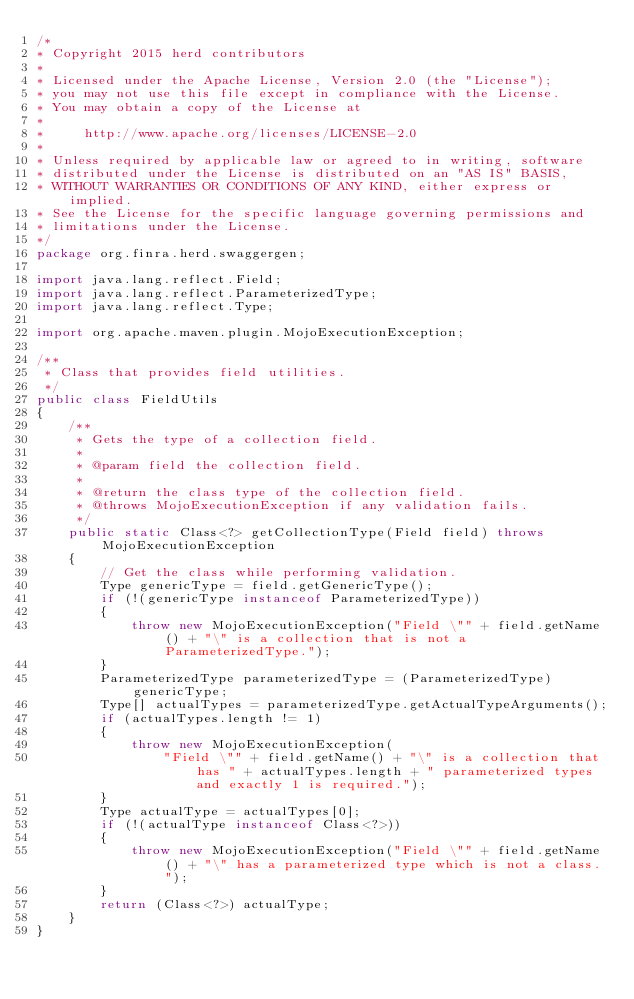Convert code to text. <code><loc_0><loc_0><loc_500><loc_500><_Java_>/*
* Copyright 2015 herd contributors
*
* Licensed under the Apache License, Version 2.0 (the "License");
* you may not use this file except in compliance with the License.
* You may obtain a copy of the License at
*
*     http://www.apache.org/licenses/LICENSE-2.0
*
* Unless required by applicable law or agreed to in writing, software
* distributed under the License is distributed on an "AS IS" BASIS,
* WITHOUT WARRANTIES OR CONDITIONS OF ANY KIND, either express or implied.
* See the License for the specific language governing permissions and
* limitations under the License.
*/
package org.finra.herd.swaggergen;

import java.lang.reflect.Field;
import java.lang.reflect.ParameterizedType;
import java.lang.reflect.Type;

import org.apache.maven.plugin.MojoExecutionException;

/**
 * Class that provides field utilities.
 */
public class FieldUtils
{
    /**
     * Gets the type of a collection field.
     *
     * @param field the collection field.
     *
     * @return the class type of the collection field.
     * @throws MojoExecutionException if any validation fails.
     */
    public static Class<?> getCollectionType(Field field) throws MojoExecutionException
    {
        // Get the class while performing validation.
        Type genericType = field.getGenericType();
        if (!(genericType instanceof ParameterizedType))
        {
            throw new MojoExecutionException("Field \"" + field.getName() + "\" is a collection that is not a ParameterizedType.");
        }
        ParameterizedType parameterizedType = (ParameterizedType) genericType;
        Type[] actualTypes = parameterizedType.getActualTypeArguments();
        if (actualTypes.length != 1)
        {
            throw new MojoExecutionException(
                "Field \"" + field.getName() + "\" is a collection that has " + actualTypes.length + " parameterized types and exactly 1 is required.");
        }
        Type actualType = actualTypes[0];
        if (!(actualType instanceof Class<?>))
        {
            throw new MojoExecutionException("Field \"" + field.getName() + "\" has a parameterized type which is not a class.");
        }
        return (Class<?>) actualType;
    }
}
</code> 